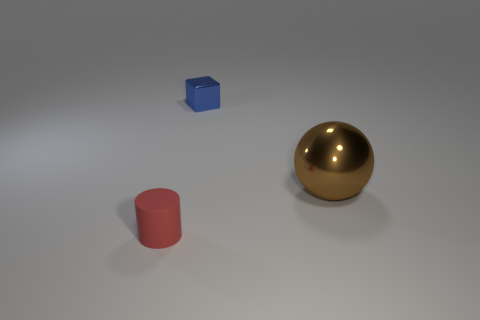Add 1 small blue shiny objects. How many objects exist? 4 Subtract all cylinders. How many objects are left? 2 Subtract all tiny green matte cubes. Subtract all tiny rubber cylinders. How many objects are left? 2 Add 1 large brown things. How many large brown things are left? 2 Add 1 big brown shiny spheres. How many big brown shiny spheres exist? 2 Subtract 1 red cylinders. How many objects are left? 2 Subtract all purple cylinders. How many red spheres are left? 0 